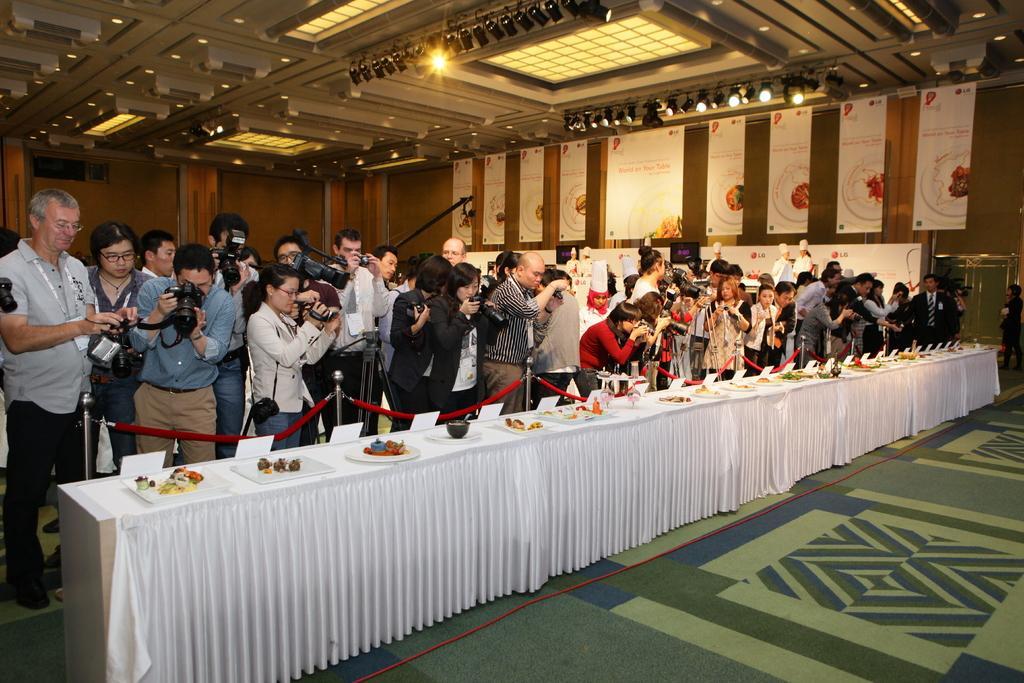Please provide a concise description of this image. As we can see in the image, there are few people standing and holding cameras in their hands. In front of them there is a long table. On table there is a white color cloth, plate and some food items and the floor is in green color. 